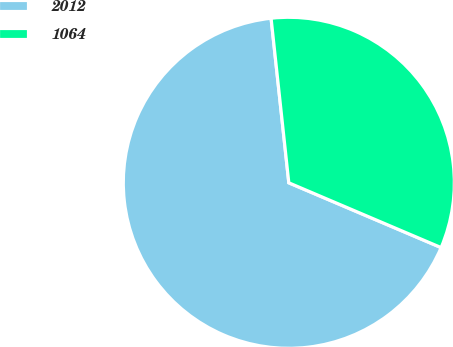Convert chart. <chart><loc_0><loc_0><loc_500><loc_500><pie_chart><fcel>2012<fcel>1064<nl><fcel>66.89%<fcel>33.11%<nl></chart> 